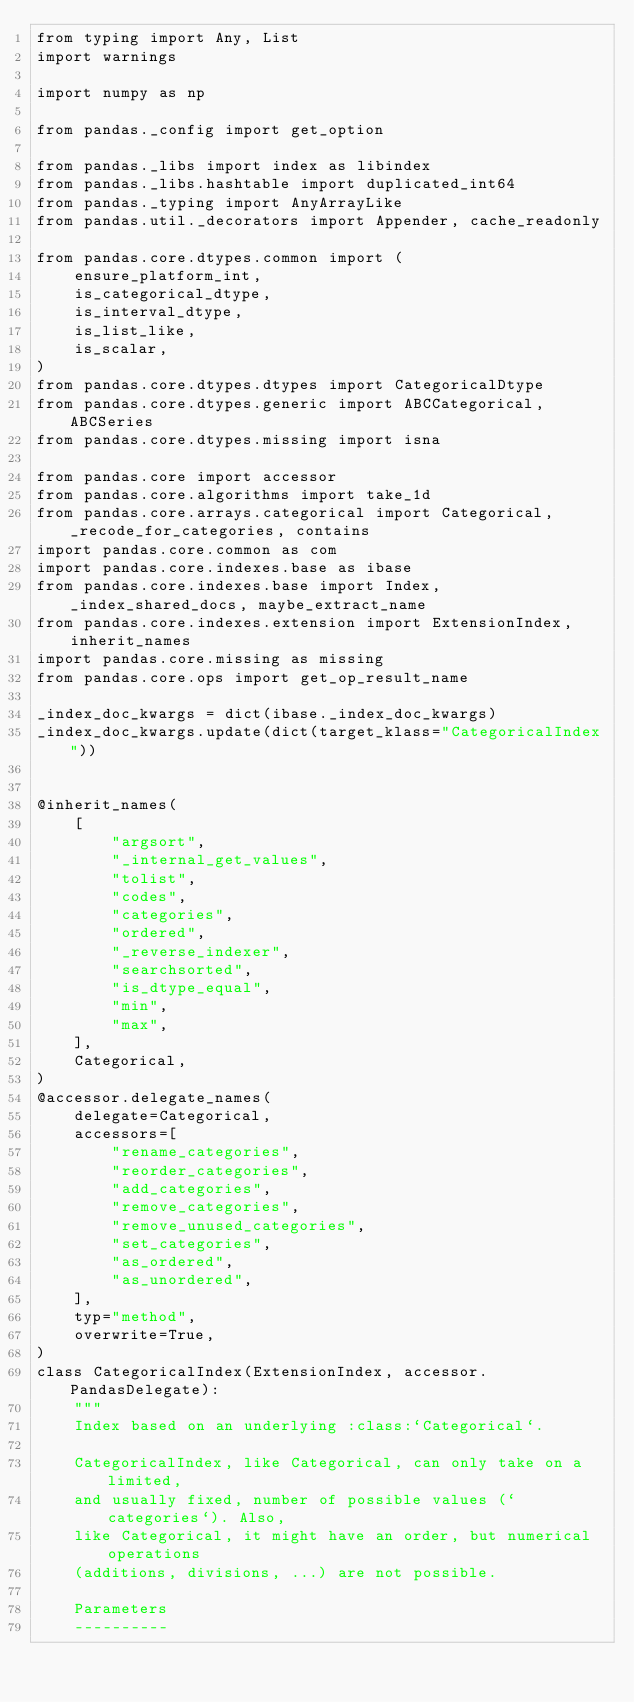Convert code to text. <code><loc_0><loc_0><loc_500><loc_500><_Python_>from typing import Any, List
import warnings

import numpy as np

from pandas._config import get_option

from pandas._libs import index as libindex
from pandas._libs.hashtable import duplicated_int64
from pandas._typing import AnyArrayLike
from pandas.util._decorators import Appender, cache_readonly

from pandas.core.dtypes.common import (
    ensure_platform_int,
    is_categorical_dtype,
    is_interval_dtype,
    is_list_like,
    is_scalar,
)
from pandas.core.dtypes.dtypes import CategoricalDtype
from pandas.core.dtypes.generic import ABCCategorical, ABCSeries
from pandas.core.dtypes.missing import isna

from pandas.core import accessor
from pandas.core.algorithms import take_1d
from pandas.core.arrays.categorical import Categorical, _recode_for_categories, contains
import pandas.core.common as com
import pandas.core.indexes.base as ibase
from pandas.core.indexes.base import Index, _index_shared_docs, maybe_extract_name
from pandas.core.indexes.extension import ExtensionIndex, inherit_names
import pandas.core.missing as missing
from pandas.core.ops import get_op_result_name

_index_doc_kwargs = dict(ibase._index_doc_kwargs)
_index_doc_kwargs.update(dict(target_klass="CategoricalIndex"))


@inherit_names(
    [
        "argsort",
        "_internal_get_values",
        "tolist",
        "codes",
        "categories",
        "ordered",
        "_reverse_indexer",
        "searchsorted",
        "is_dtype_equal",
        "min",
        "max",
    ],
    Categorical,
)
@accessor.delegate_names(
    delegate=Categorical,
    accessors=[
        "rename_categories",
        "reorder_categories",
        "add_categories",
        "remove_categories",
        "remove_unused_categories",
        "set_categories",
        "as_ordered",
        "as_unordered",
    ],
    typ="method",
    overwrite=True,
)
class CategoricalIndex(ExtensionIndex, accessor.PandasDelegate):
    """
    Index based on an underlying :class:`Categorical`.

    CategoricalIndex, like Categorical, can only take on a limited,
    and usually fixed, number of possible values (`categories`). Also,
    like Categorical, it might have an order, but numerical operations
    (additions, divisions, ...) are not possible.

    Parameters
    ----------</code> 